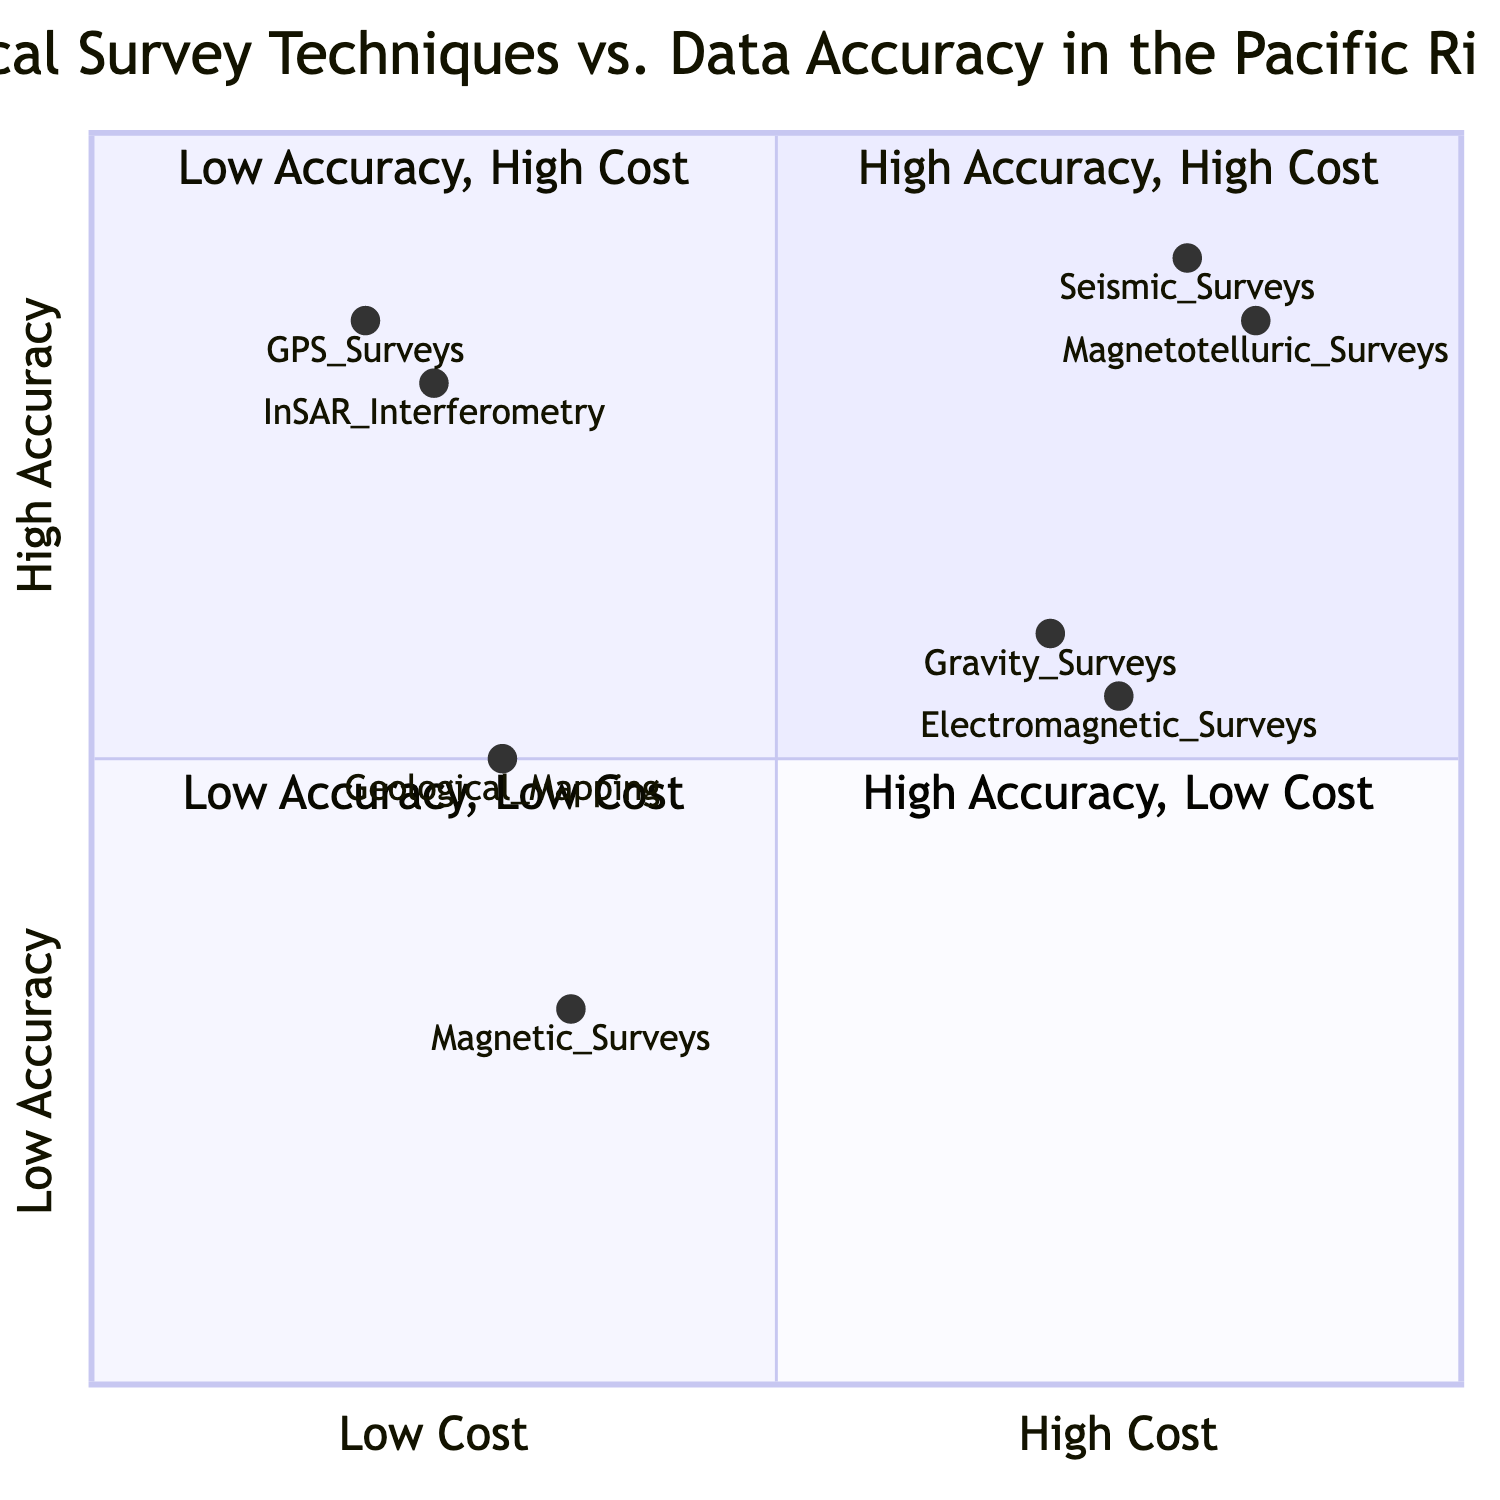What survey technique has the highest accuracy and high cost? By examining the quadrant labeled "High Accuracy, High Cost", we can identify that both Seismic Surveys and Magnetotelluric Surveys fall within this category, but the question requires identifying any one technique, so either can serve as the answer.
Answer: Seismic Surveys What is the accuracy level of Gravity Surveys? Gravity Surveys are placed in the quadrant labeled "Low Accuracy, High Cost." The diagram indicates that the accuracy level is "Moderate".
Answer: Moderate Which location is associated with GPS Surveys? GPS Surveys are listed in the quadrant labeled "High Accuracy, Low Cost" with the corresponding location identified as "San Andreas Fault".
Answer: San Andreas Fault How many survey techniques are categorized under High Accuracy, Low Cost? In the quadrant labeled "High Accuracy, Low Cost", there are two techniques highlighted: GPS Surveys and InSAR Interferometry. Hence, the total number of techniques is two.
Answer: 2 Which survey technique has the lowest accuracy and low cost? The quadrant labeled "Low Accuracy, Low Cost" contains Magnetic Surveys. This means that among the various techniques surveyed, Magnetic Surveys represent the least accurate and most cost-effective option.
Answer: Magnetic Surveys What cost category does Magnetotelluric Surveys fall into? Magnetotelluric Surveys are shown in the "High Accuracy, High Cost" quadrant, which clearly categorizes them as high cost as indicated by their position in the diagram.
Answer: High Cost Which method was used in the Vanuatu Arc survey? Reviewing the quadrant labeled "Low Accuracy, High Cost," we can find that the method employed for the Gravity Surveys in the Vanuatu Arc is specified as "Airborne Gravity Survey".
Answer: Airborne Gravity Survey What is the accuracy of InSAR Interferometry? InSAR Interferometry is located in the quadrant labeled "High Accuracy, Low Cost", which indicates that its accuracy level is categorized as "High".
Answer: High Which technique shows a moderate accuracy level among low-cost methods? In the "Low Accuracy, Low Cost" quadrant, Geological Mapping is indicated as having a moderate level of accuracy. Therefore, it is the technique that fits the criteria of moderate accuracy in the low-cost category.
Answer: Geological Mapping 